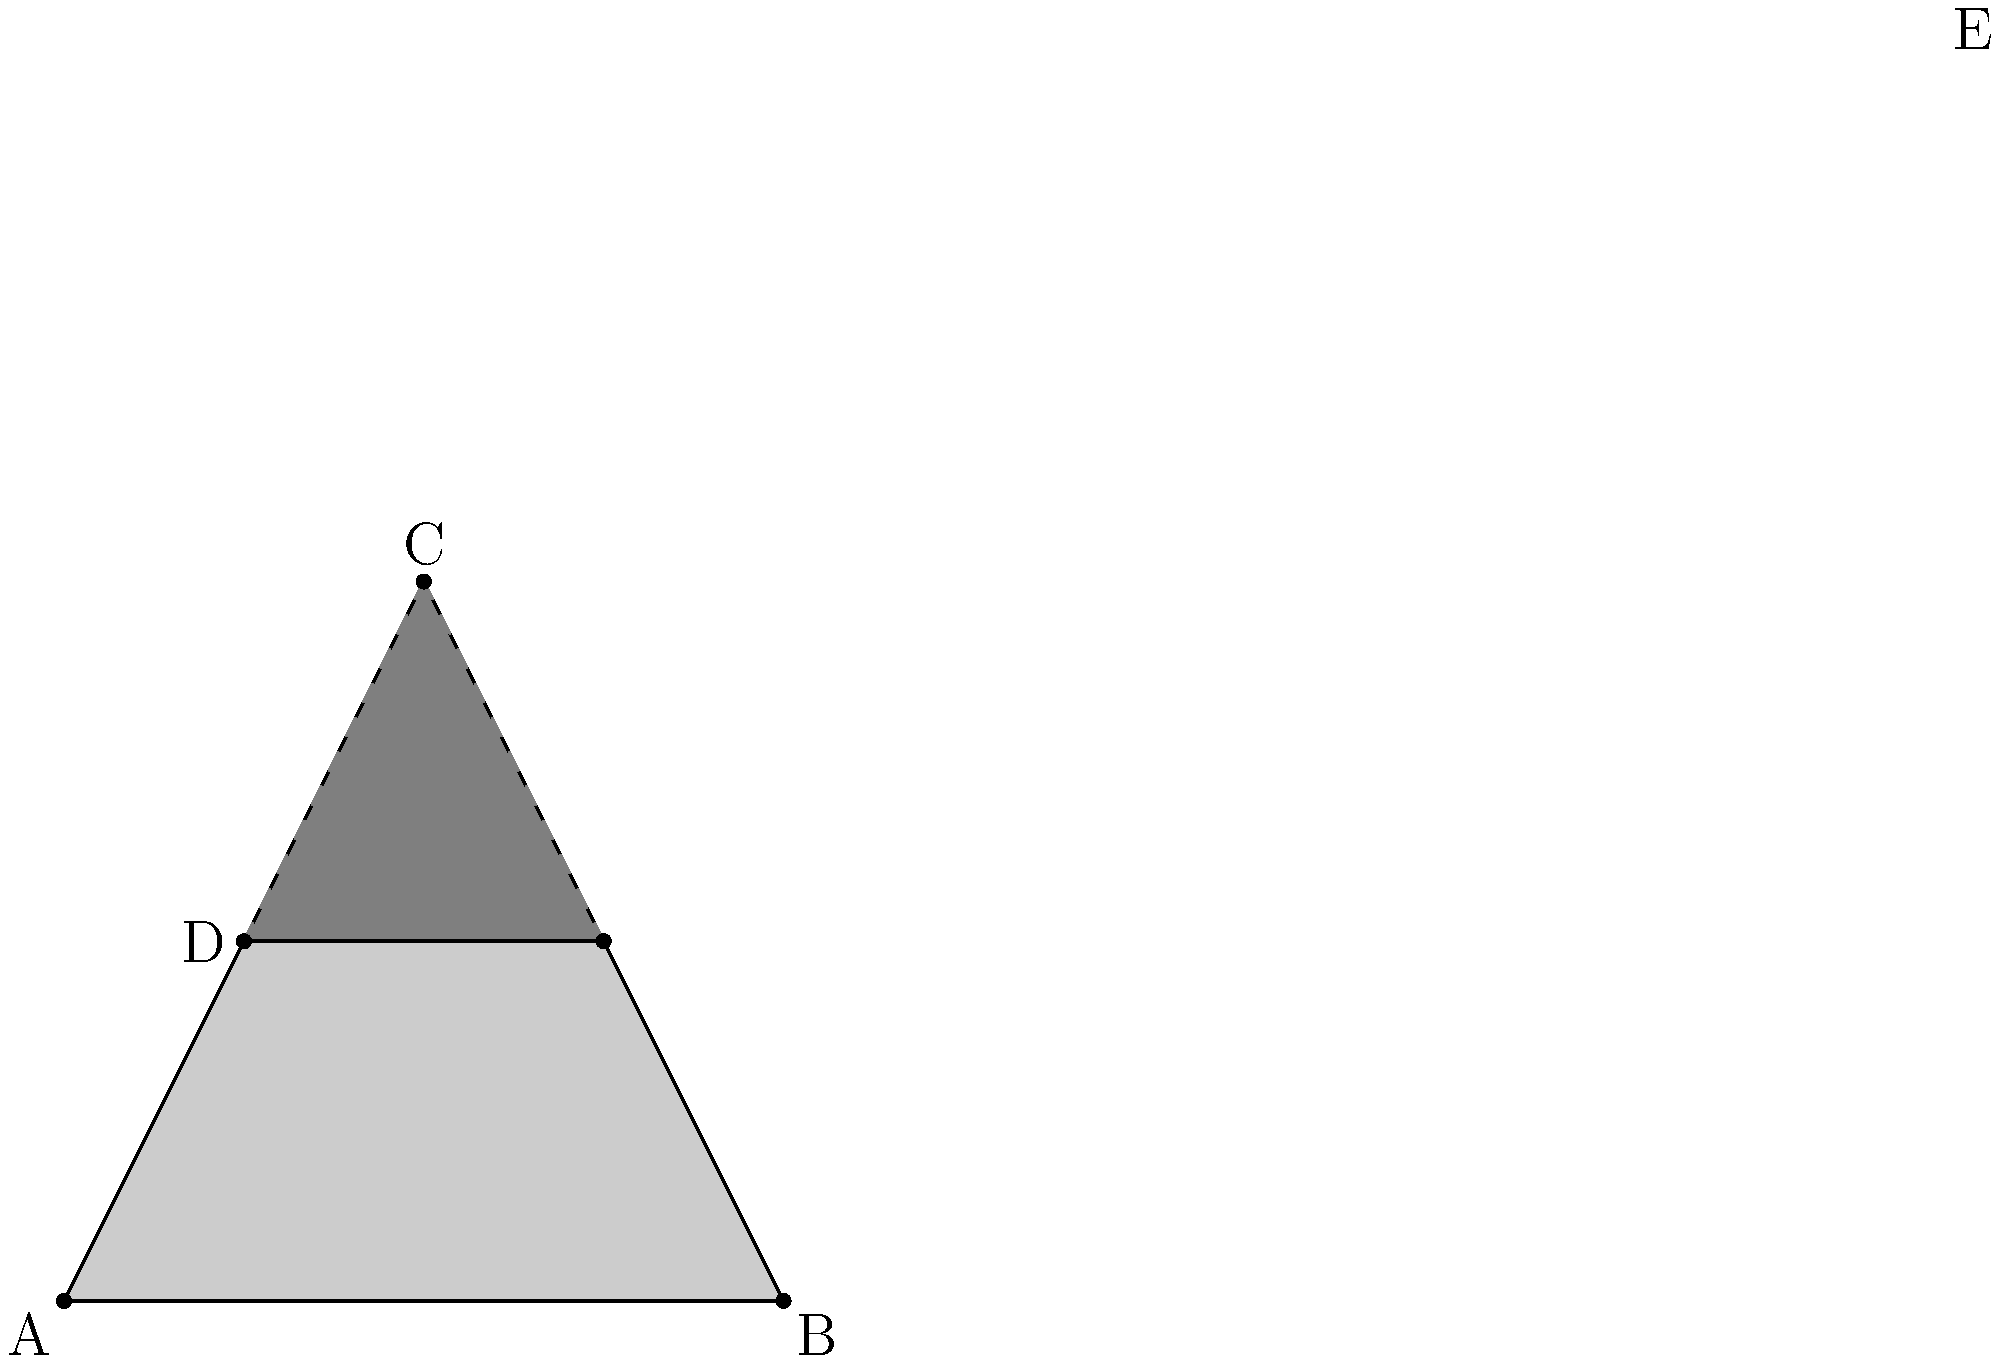In the shadows of a dimly lit alley, two streetlights cast overlapping shadows, forming a complex web of darkness. The intersection of these shadows creates a triangle DEF, where D and E are the midpoints of sides AC and BC of the larger triangle ABC. If the area of triangle ABC is 100 square units, what is the area of the darker, overlapping shadow represented by triangle DEF? To solve this noir-tinged geometric puzzle, we'll follow these shadowy steps:

1) First, we need to recall the midpoint theorem: A line segment joining the midpoints of two sides of a triangle is parallel to the third side and half the length.

2) Since D and E are midpoints of AC and BC respectively, DE is parallel to AB and half its length.

3) This means triangle DEF is similar to triangle ABC, with a scale factor of 1/2.

4) When a triangle is similar with a scale factor of k, its area is reduced by a factor of $k^2$.

5) In this case, $k = 1/2$, so the area ratio is:

   $\frac{\text{Area of DEF}}{\text{Area of ABC}} = (\frac{1}{2})^2 = \frac{1}{4}$

6) We're given that the area of ABC is 100 square units, so:

   $\text{Area of DEF} = \frac{1}{4} \times 100 = 25$ square units

Thus, the darker shadow where fates intertwine occupies 25 square units, a quarter of the larger triangle's area, much like how our characters' destinies are but a fraction of the larger, shadowy world they inhabit.
Answer: 25 square units 